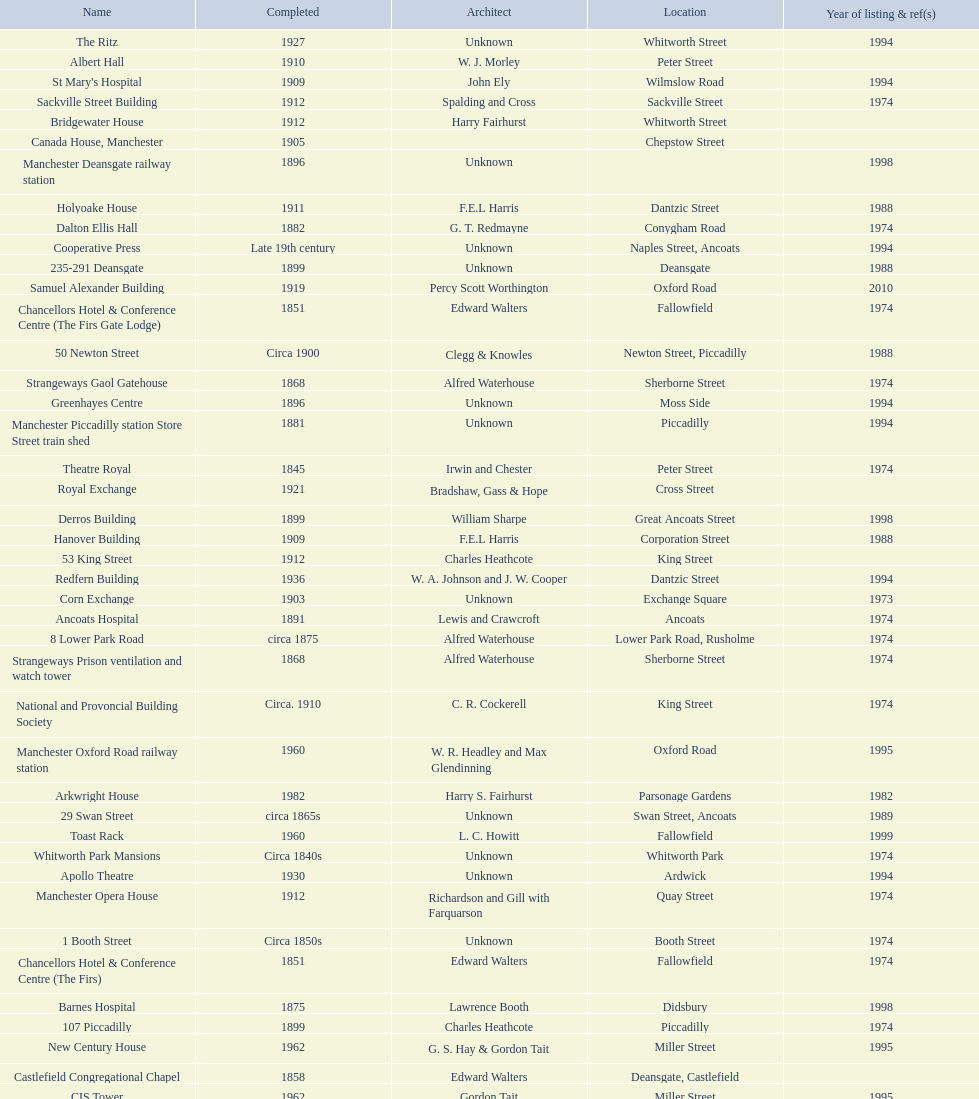How many buildings had alfred waterhouse as their architect? 3. 